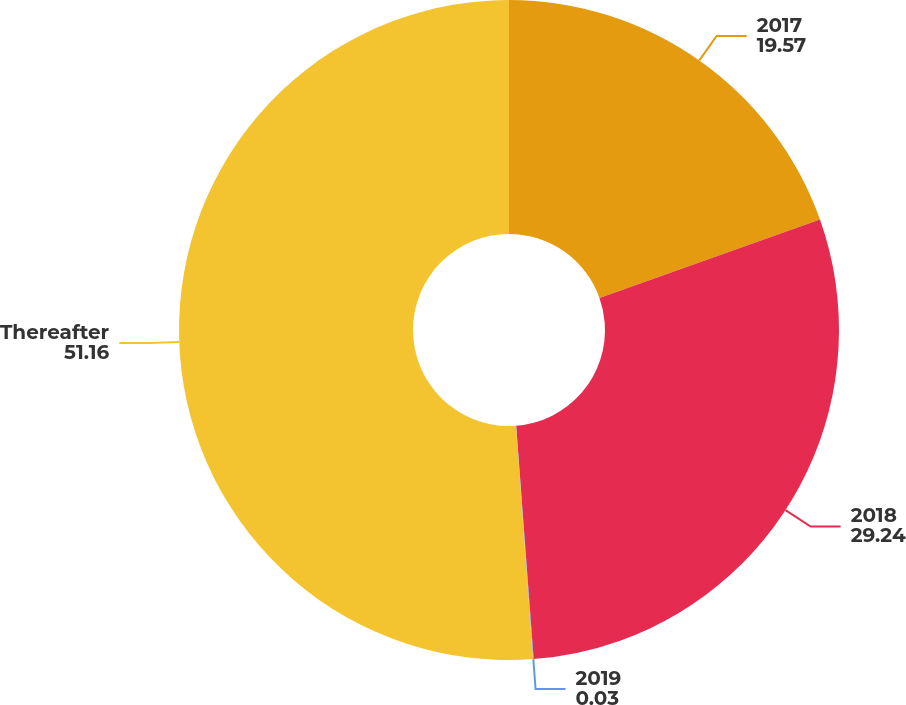<chart> <loc_0><loc_0><loc_500><loc_500><pie_chart><fcel>2017<fcel>2018<fcel>2019<fcel>Thereafter<nl><fcel>19.57%<fcel>29.24%<fcel>0.03%<fcel>51.16%<nl></chart> 